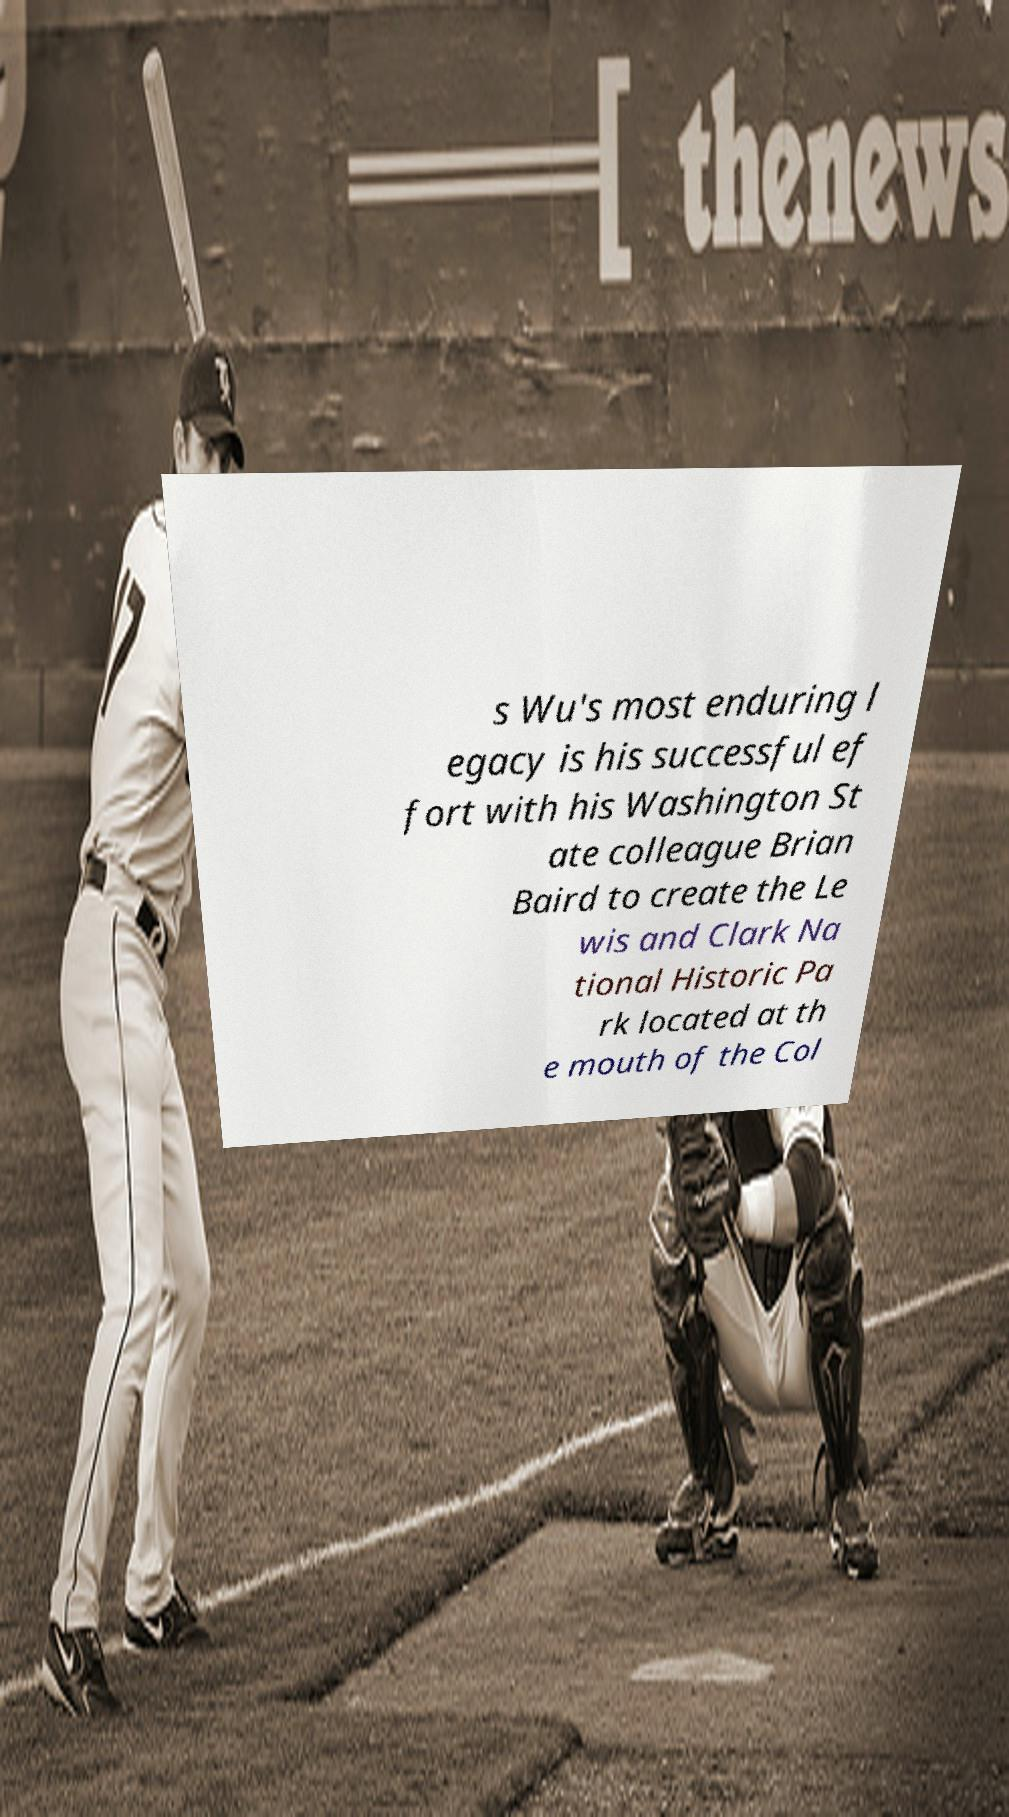What messages or text are displayed in this image? I need them in a readable, typed format. s Wu's most enduring l egacy is his successful ef fort with his Washington St ate colleague Brian Baird to create the Le wis and Clark Na tional Historic Pa rk located at th e mouth of the Col 